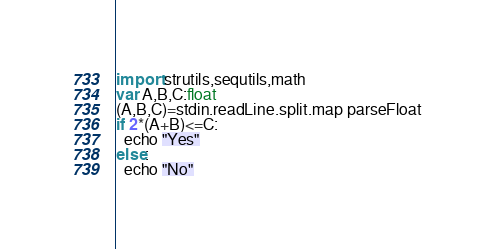Convert code to text. <code><loc_0><loc_0><loc_500><loc_500><_Nim_>import strutils,sequtils,math
var A,B,C:float
(A,B,C)=stdin.readLine.split.map parseFloat
if 2*(A+B)<=C:
  echo "Yes"
else:
  echo "No"</code> 